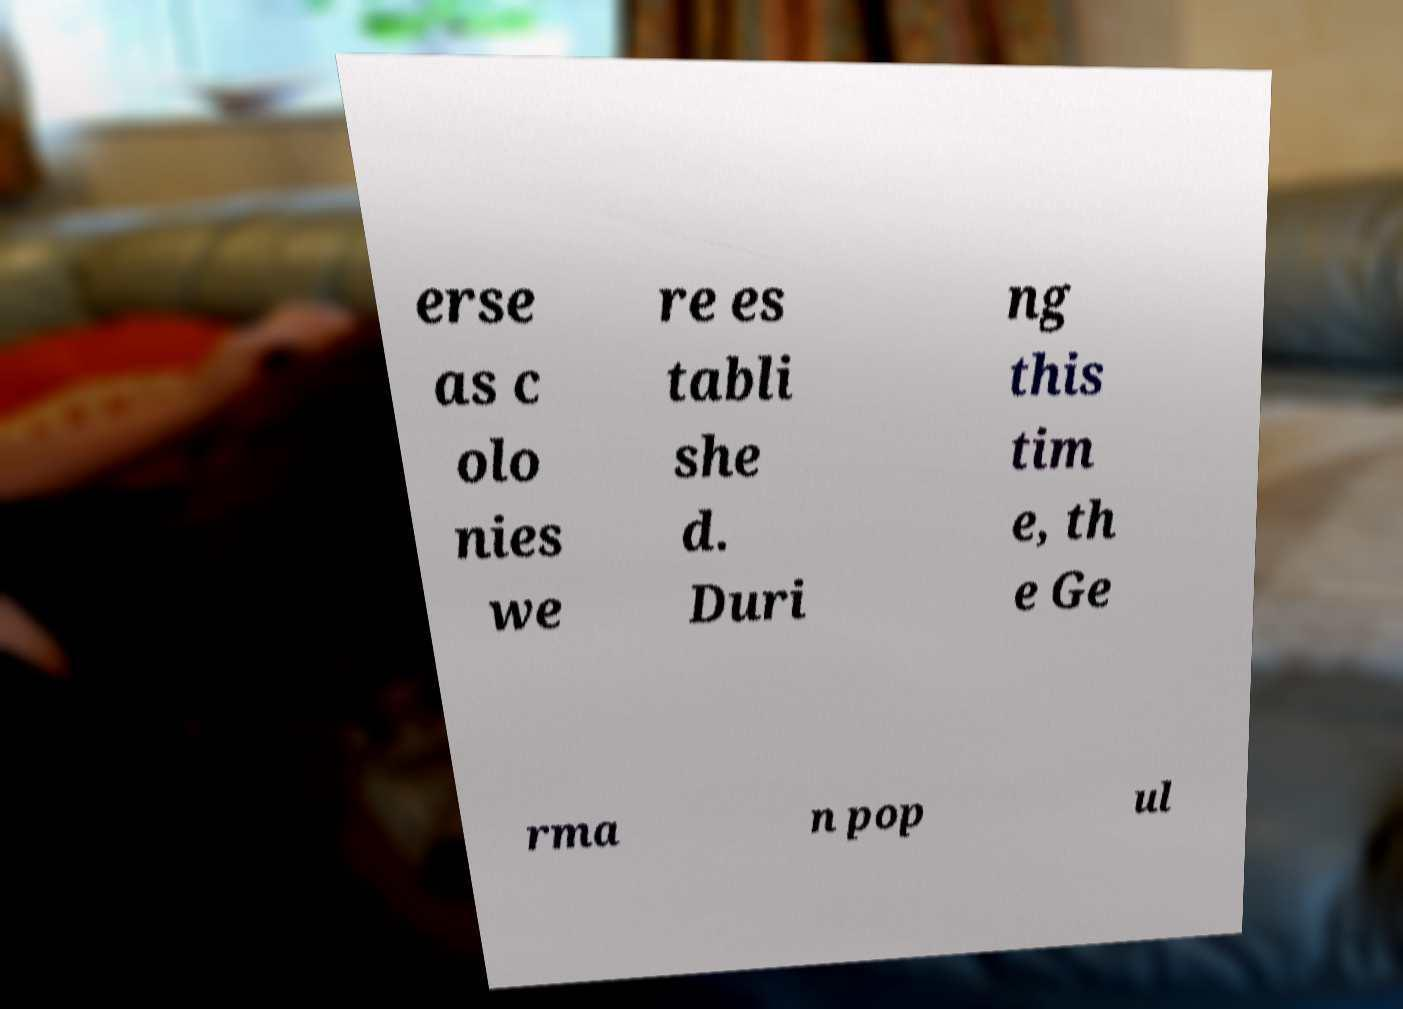Please read and relay the text visible in this image. What does it say? erse as c olo nies we re es tabli she d. Duri ng this tim e, th e Ge rma n pop ul 